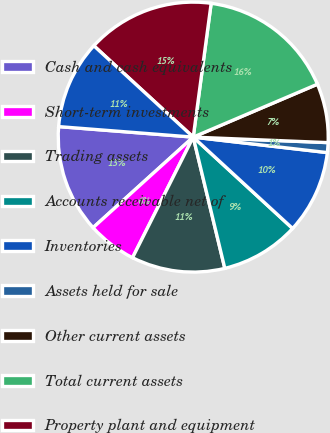Convert chart to OTSL. <chart><loc_0><loc_0><loc_500><loc_500><pie_chart><fcel>Cash and cash equivalents<fcel>Short-term investments<fcel>Trading assets<fcel>Accounts receivable net of<fcel>Inventories<fcel>Assets held for sale<fcel>Other current assets<fcel>Total current assets<fcel>Property plant and equipment<fcel>Marketable equity securities<nl><fcel>12.94%<fcel>5.88%<fcel>11.18%<fcel>9.41%<fcel>10.0%<fcel>1.18%<fcel>7.06%<fcel>16.47%<fcel>15.29%<fcel>10.59%<nl></chart> 